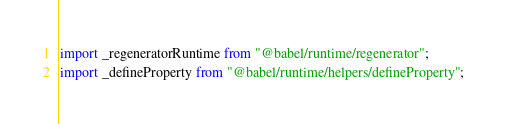<code> <loc_0><loc_0><loc_500><loc_500><_JavaScript_>import _regeneratorRuntime from "@babel/runtime/regenerator";
import _defineProperty from "@babel/runtime/helpers/defineProperty";</code> 